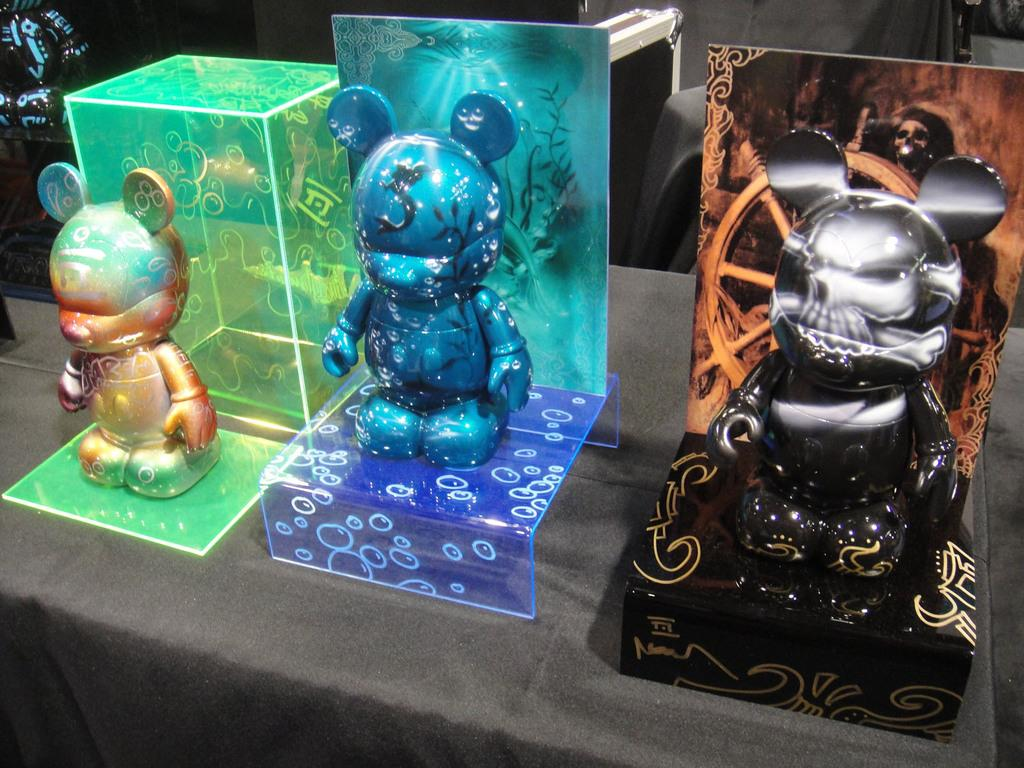What is the color of the surface in the image? The surface in the image is black. What can be found on the black surface? There are toys on the black surface. What type of produce can be seen growing on the black surface in the image? There is no produce visible in the image; it features a black surface with toys on it. What is the taste of the black surface in the image? The taste of the black surface cannot be determined from the image, as it is a visual representation and not a sensory experience. 